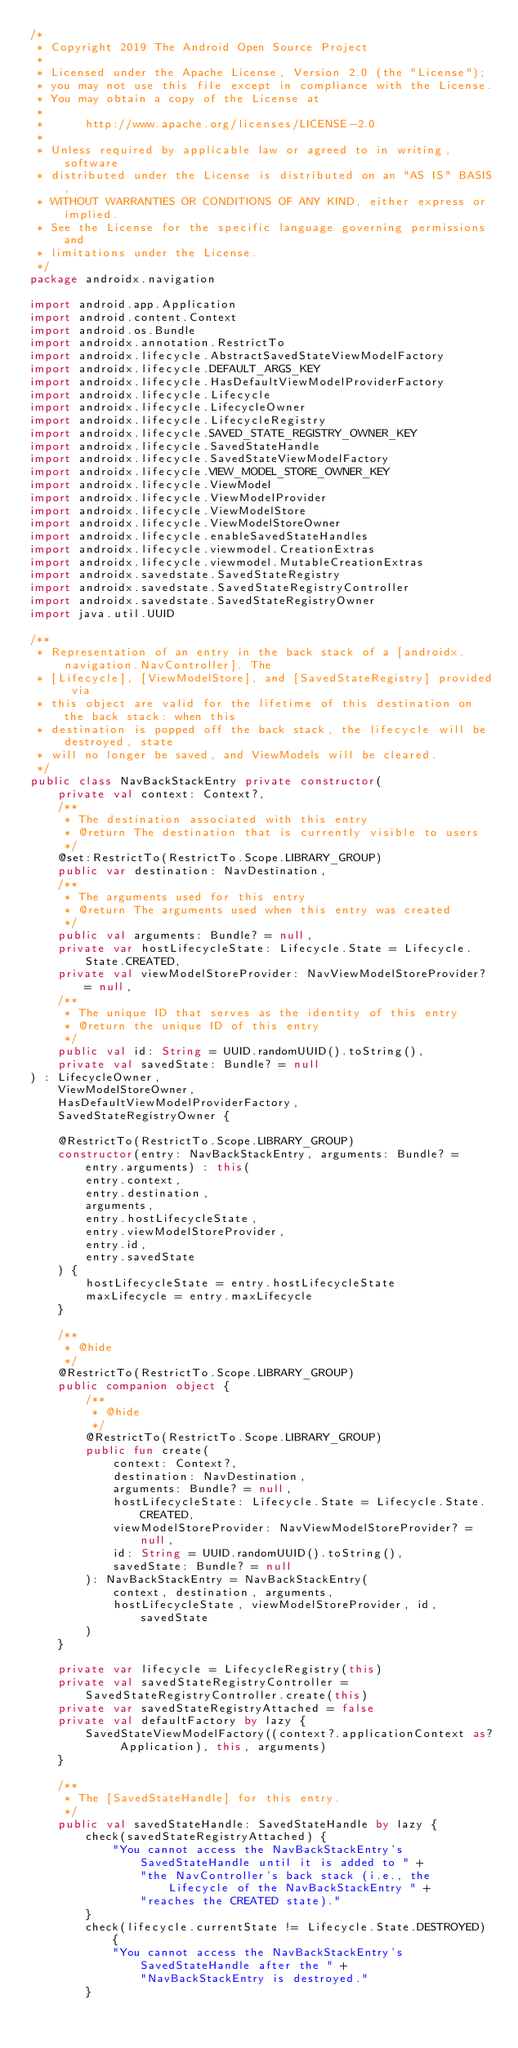<code> <loc_0><loc_0><loc_500><loc_500><_Kotlin_>/*
 * Copyright 2019 The Android Open Source Project
 *
 * Licensed under the Apache License, Version 2.0 (the "License");
 * you may not use this file except in compliance with the License.
 * You may obtain a copy of the License at
 *
 *      http://www.apache.org/licenses/LICENSE-2.0
 *
 * Unless required by applicable law or agreed to in writing, software
 * distributed under the License is distributed on an "AS IS" BASIS,
 * WITHOUT WARRANTIES OR CONDITIONS OF ANY KIND, either express or implied.
 * See the License for the specific language governing permissions and
 * limitations under the License.
 */
package androidx.navigation

import android.app.Application
import android.content.Context
import android.os.Bundle
import androidx.annotation.RestrictTo
import androidx.lifecycle.AbstractSavedStateViewModelFactory
import androidx.lifecycle.DEFAULT_ARGS_KEY
import androidx.lifecycle.HasDefaultViewModelProviderFactory
import androidx.lifecycle.Lifecycle
import androidx.lifecycle.LifecycleOwner
import androidx.lifecycle.LifecycleRegistry
import androidx.lifecycle.SAVED_STATE_REGISTRY_OWNER_KEY
import androidx.lifecycle.SavedStateHandle
import androidx.lifecycle.SavedStateViewModelFactory
import androidx.lifecycle.VIEW_MODEL_STORE_OWNER_KEY
import androidx.lifecycle.ViewModel
import androidx.lifecycle.ViewModelProvider
import androidx.lifecycle.ViewModelStore
import androidx.lifecycle.ViewModelStoreOwner
import androidx.lifecycle.enableSavedStateHandles
import androidx.lifecycle.viewmodel.CreationExtras
import androidx.lifecycle.viewmodel.MutableCreationExtras
import androidx.savedstate.SavedStateRegistry
import androidx.savedstate.SavedStateRegistryController
import androidx.savedstate.SavedStateRegistryOwner
import java.util.UUID

/**
 * Representation of an entry in the back stack of a [androidx.navigation.NavController]. The
 * [Lifecycle], [ViewModelStore], and [SavedStateRegistry] provided via
 * this object are valid for the lifetime of this destination on the back stack: when this
 * destination is popped off the back stack, the lifecycle will be destroyed, state
 * will no longer be saved, and ViewModels will be cleared.
 */
public class NavBackStackEntry private constructor(
    private val context: Context?,
    /**
     * The destination associated with this entry
     * @return The destination that is currently visible to users
     */
    @set:RestrictTo(RestrictTo.Scope.LIBRARY_GROUP)
    public var destination: NavDestination,
    /**
     * The arguments used for this entry
     * @return The arguments used when this entry was created
     */
    public val arguments: Bundle? = null,
    private var hostLifecycleState: Lifecycle.State = Lifecycle.State.CREATED,
    private val viewModelStoreProvider: NavViewModelStoreProvider? = null,
    /**
     * The unique ID that serves as the identity of this entry
     * @return the unique ID of this entry
     */
    public val id: String = UUID.randomUUID().toString(),
    private val savedState: Bundle? = null
) : LifecycleOwner,
    ViewModelStoreOwner,
    HasDefaultViewModelProviderFactory,
    SavedStateRegistryOwner {

    @RestrictTo(RestrictTo.Scope.LIBRARY_GROUP)
    constructor(entry: NavBackStackEntry, arguments: Bundle? = entry.arguments) : this(
        entry.context,
        entry.destination,
        arguments,
        entry.hostLifecycleState,
        entry.viewModelStoreProvider,
        entry.id,
        entry.savedState
    ) {
        hostLifecycleState = entry.hostLifecycleState
        maxLifecycle = entry.maxLifecycle
    }

    /**
     * @hide
     */
    @RestrictTo(RestrictTo.Scope.LIBRARY_GROUP)
    public companion object {
        /**
         * @hide
         */
        @RestrictTo(RestrictTo.Scope.LIBRARY_GROUP)
        public fun create(
            context: Context?,
            destination: NavDestination,
            arguments: Bundle? = null,
            hostLifecycleState: Lifecycle.State = Lifecycle.State.CREATED,
            viewModelStoreProvider: NavViewModelStoreProvider? = null,
            id: String = UUID.randomUUID().toString(),
            savedState: Bundle? = null
        ): NavBackStackEntry = NavBackStackEntry(
            context, destination, arguments,
            hostLifecycleState, viewModelStoreProvider, id, savedState
        )
    }

    private var lifecycle = LifecycleRegistry(this)
    private val savedStateRegistryController = SavedStateRegistryController.create(this)
    private var savedStateRegistryAttached = false
    private val defaultFactory by lazy {
        SavedStateViewModelFactory((context?.applicationContext as? Application), this, arguments)
    }

    /**
     * The [SavedStateHandle] for this entry.
     */
    public val savedStateHandle: SavedStateHandle by lazy {
        check(savedStateRegistryAttached) {
            "You cannot access the NavBackStackEntry's SavedStateHandle until it is added to " +
                "the NavController's back stack (i.e., the Lifecycle of the NavBackStackEntry " +
                "reaches the CREATED state)."
        }
        check(lifecycle.currentState != Lifecycle.State.DESTROYED) {
            "You cannot access the NavBackStackEntry's SavedStateHandle after the " +
                "NavBackStackEntry is destroyed."
        }</code> 